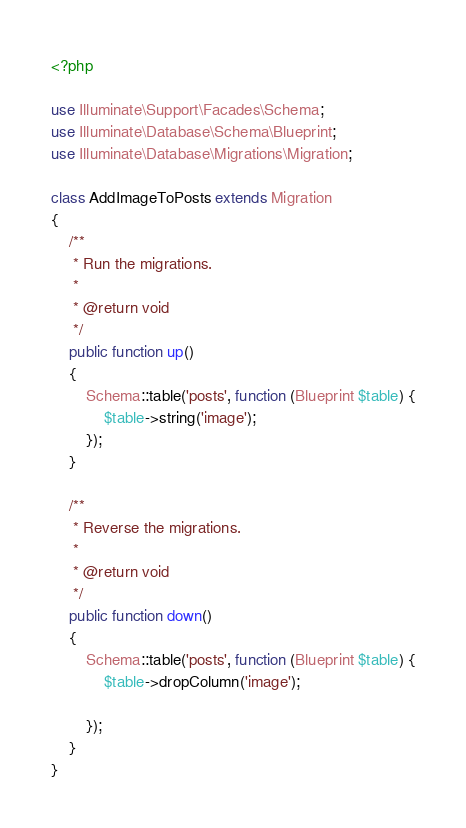<code> <loc_0><loc_0><loc_500><loc_500><_PHP_><?php

use Illuminate\Support\Facades\Schema;
use Illuminate\Database\Schema\Blueprint;
use Illuminate\Database\Migrations\Migration;

class AddImageToPosts extends Migration
{
    /**
     * Run the migrations.
     *
     * @return void
     */
    public function up()
    {
        Schema::table('posts', function (Blueprint $table) {
            $table->string('image');
        });
    }

    /**
     * Reverse the migrations.
     *
     * @return void
     */
    public function down()
    {
        Schema::table('posts', function (Blueprint $table) {
            $table->dropColumn('image');

        });
    }
}
</code> 